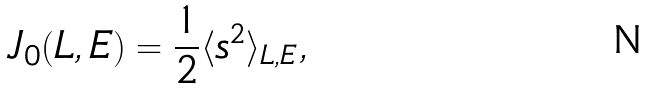Convert formula to latex. <formula><loc_0><loc_0><loc_500><loc_500>J _ { 0 } ( L , E ) = \frac { 1 } { 2 } \langle s ^ { 2 } \rangle _ { L , E } ,</formula> 